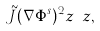<formula> <loc_0><loc_0><loc_500><loc_500>\tilde { J } ( \nabla \Phi ^ { s } ) ^ { 2 } z ^ { \dagger } z ,</formula> 